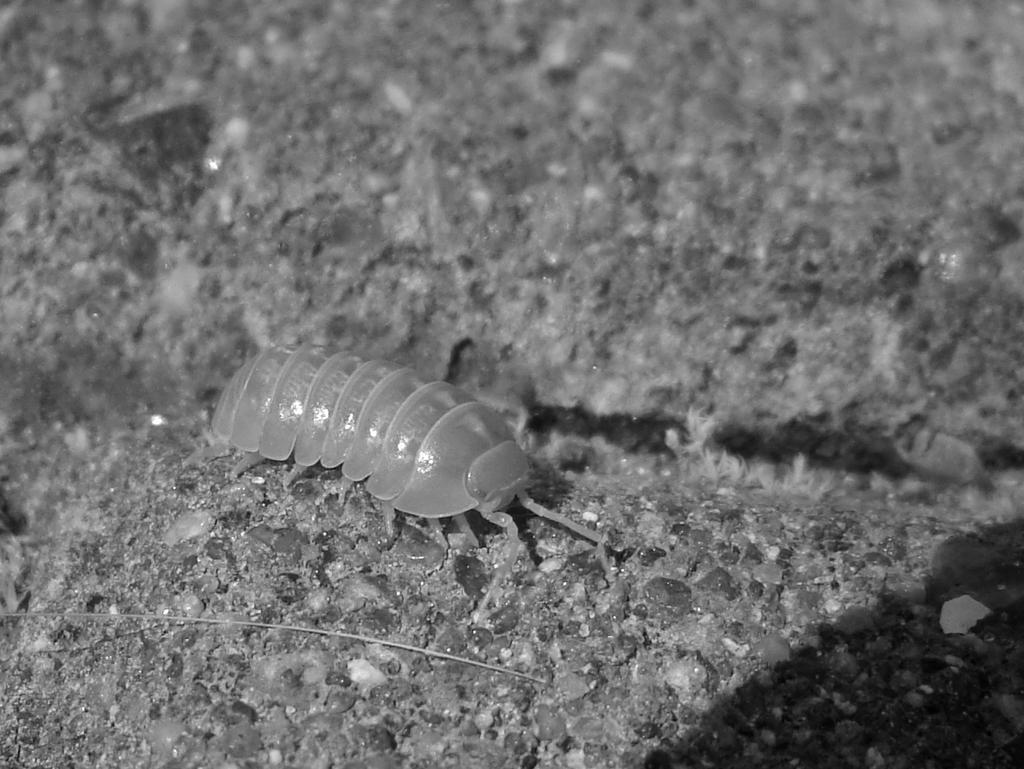What is on the ground in the image? There is an insect on the ground, and the ground has stones on it. Can you describe the ground's surface in the image? The ground has stones on it, both in the foreground and the background. What is visible on the right side of the image? There is a shadow of an object on the right side. What type of statement can be seen on the sofa in the image? There is no sofa present in the image, and therefore no statement can be seen on it. What color is the flesh of the insect in the image? The provided facts do not mention the color of the insect's flesh, and it is not possible to determine this information from the image alone. 